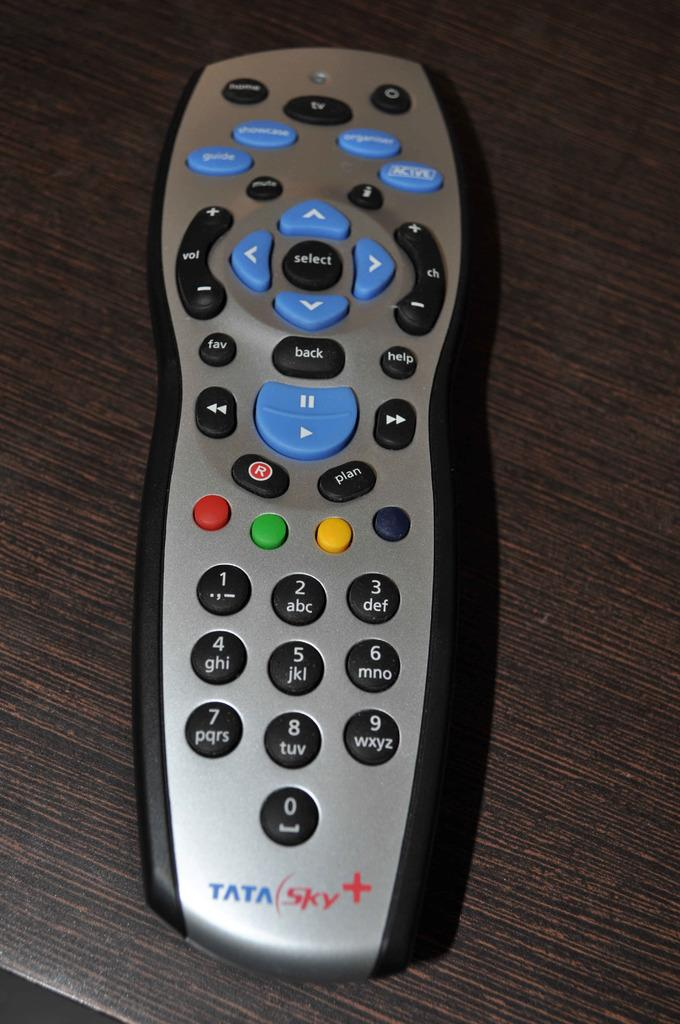<image>
Present a compact description of the photo's key features. Tata Sky plus tv remote with buttons to work the television. 